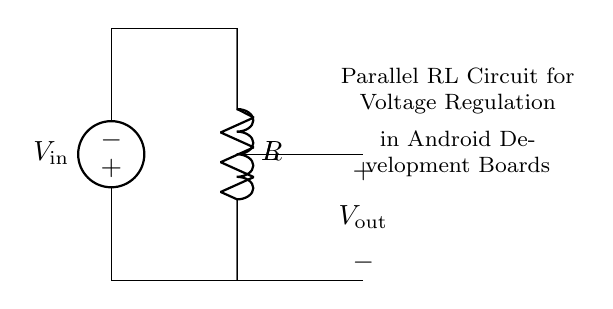What type of circuit is depicted? The diagram represents a parallel RL circuit, indicated by the simultaneous placement of a resistor and an inductor connected across the same input voltage.
Answer: Parallel RL circuit What is the voltage supply labeled as? The voltage supply in the circuit is labeled as V in, which is positioned at the top of the diagram, providing the necessary input voltage to the circuit components below it.
Answer: V in How many components are connected in parallel in this circuit? There are two components connected in parallel: one resistor and one inductor, which share the same two terminals, allowing for parallel operation.
Answer: Two What is the role of the resistor in this circuit? The resistor in this parallel RL circuit primarily limits the current flow and contributes to voltage regulation, helping to stabilize the output voltage.
Answer: Limits current What is the output voltage connection labeled as? The output voltage connection in this circuit is labeled as V out, demonstrating the point at which the regulated voltage is taken from the parallel RL network.
Answer: V out How does the inductor affect the circuit during sudden current changes? The inductor opposes sudden changes in current due to its property of inductance, causing the current flow to ramp up or down gradually rather than instantaneously, which contributes to smoothing the voltage fluctuations.
Answer: Smooths voltage 